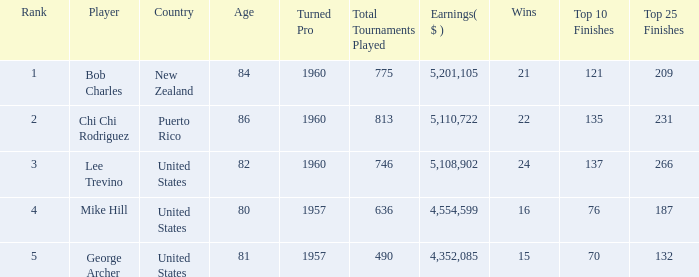In total, how much did the United States player George Archer earn with Wins lower than 24 and a rank that was higher than 5? 0.0. Could you help me parse every detail presented in this table? {'header': ['Rank', 'Player', 'Country', 'Age', 'Turned Pro', 'Total Tournaments Played', 'Earnings( $ )', 'Wins', 'Top 10 Finishes', 'Top 25 Finishes'], 'rows': [['1', 'Bob Charles', 'New Zealand', '84', '1960', '775', '5,201,105', '21', '121', '209'], ['2', 'Chi Chi Rodriguez', 'Puerto Rico', '86', '1960', '813', '5,110,722', '22', '135', '231'], ['3', 'Lee Trevino', 'United States', '82', '1960', '746', '5,108,902', '24', '137', '266'], ['4', 'Mike Hill', 'United States', '80', '1957', '636', '4,554,599', '16', '76', '187'], ['5', 'George Archer', 'United States', '81', '1957', '490', '4,352,085', '15', '70', '132']]} 